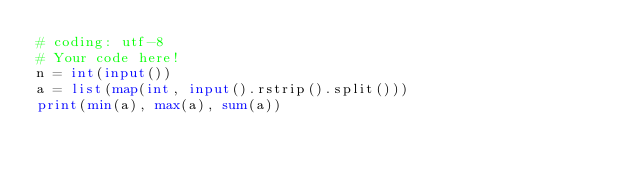<code> <loc_0><loc_0><loc_500><loc_500><_Python_># coding: utf-8
# Your code here!
n = int(input())
a = list(map(int, input().rstrip().split()))
print(min(a), max(a), sum(a))

</code> 